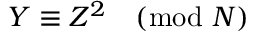<formula> <loc_0><loc_0><loc_500><loc_500>Y \equiv Z ^ { 2 } { \pmod { N } }</formula> 